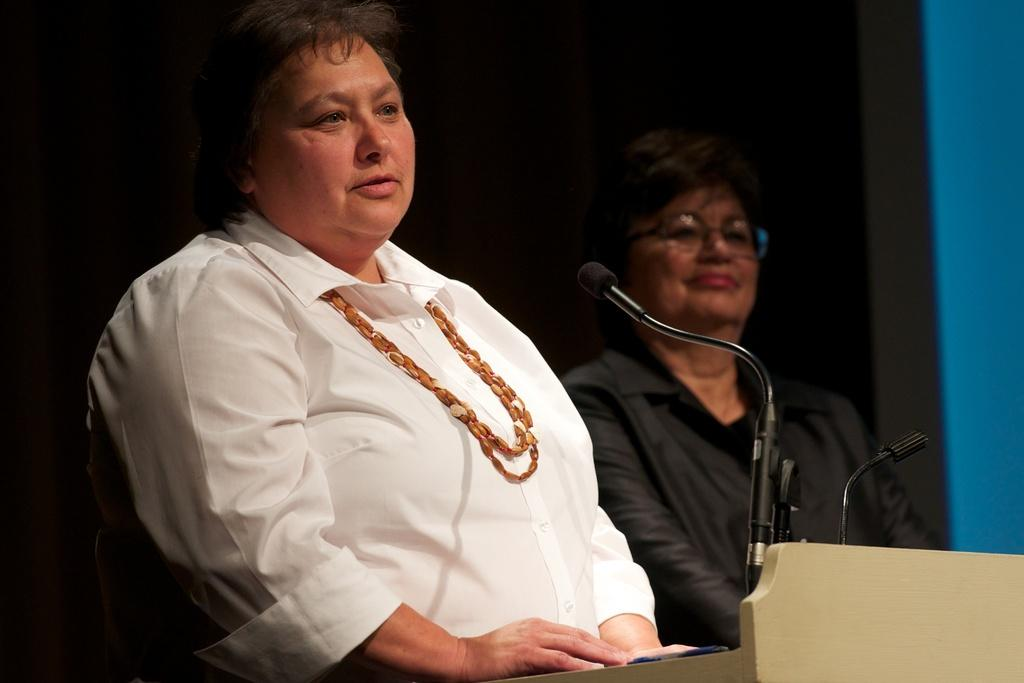How many women are in the image? There are two women in the image. What are the women wearing? One woman is wearing a white shirt, and the other woman is wearing a black dress. What objects can be seen in the image that are typically used for amplifying sound? There are microphones visible in the image. What is the color of the background in the image? The background of the image is dark. What type of pickle is being used as a prop in the image? There is no pickle present in the image. How does the jelly contribute to the overall theme of the image? There is no jelly present in the image. 